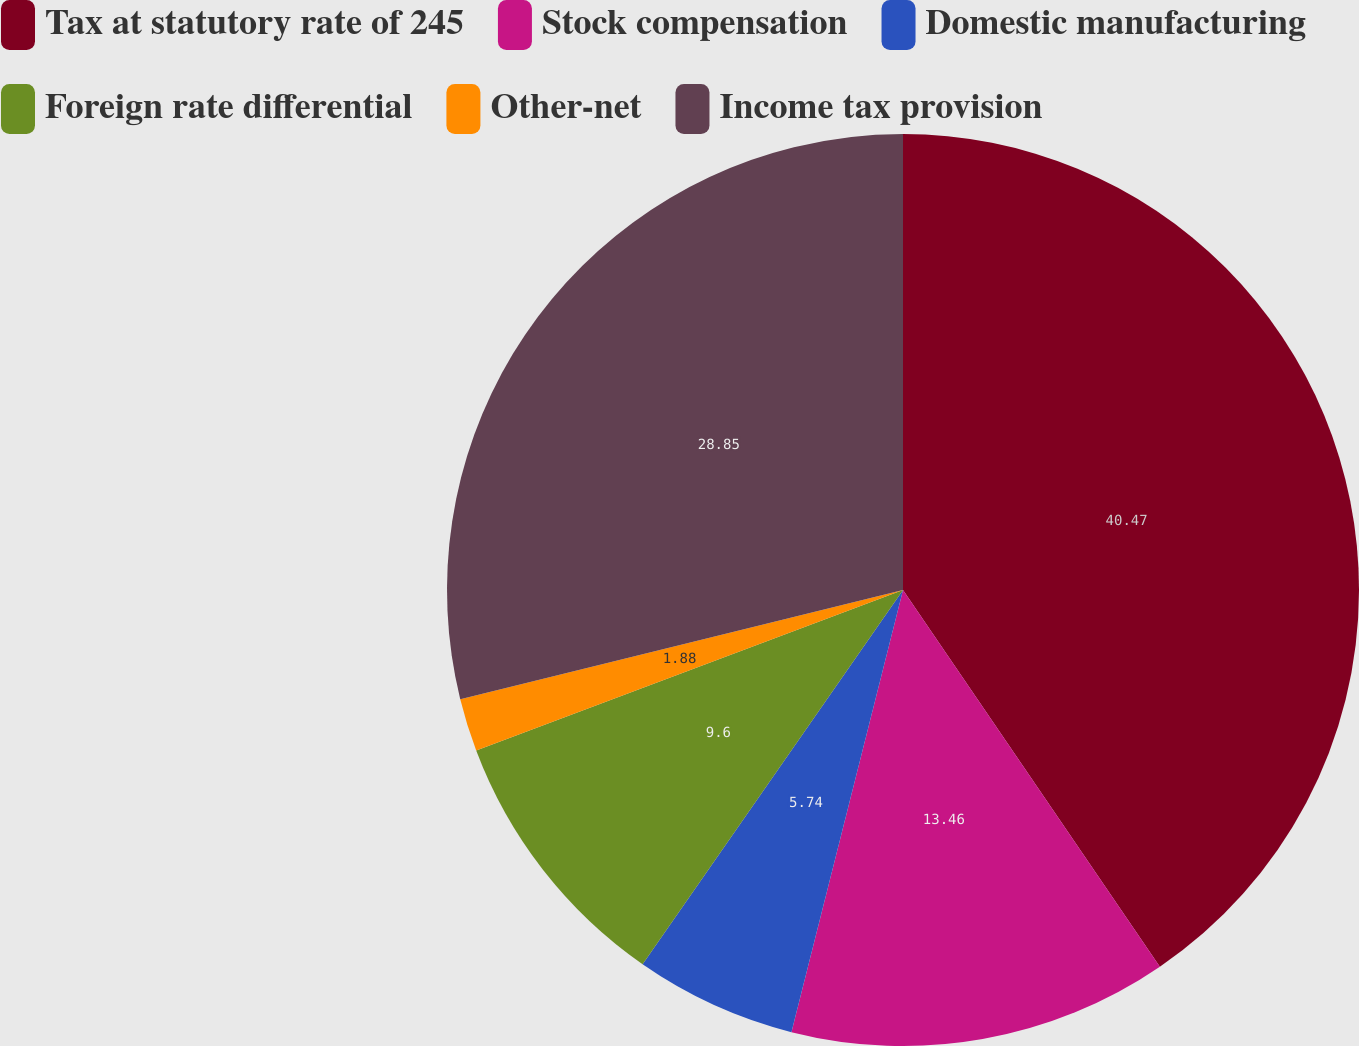Convert chart to OTSL. <chart><loc_0><loc_0><loc_500><loc_500><pie_chart><fcel>Tax at statutory rate of 245<fcel>Stock compensation<fcel>Domestic manufacturing<fcel>Foreign rate differential<fcel>Other-net<fcel>Income tax provision<nl><fcel>40.48%<fcel>13.46%<fcel>5.74%<fcel>9.6%<fcel>1.88%<fcel>28.85%<nl></chart> 